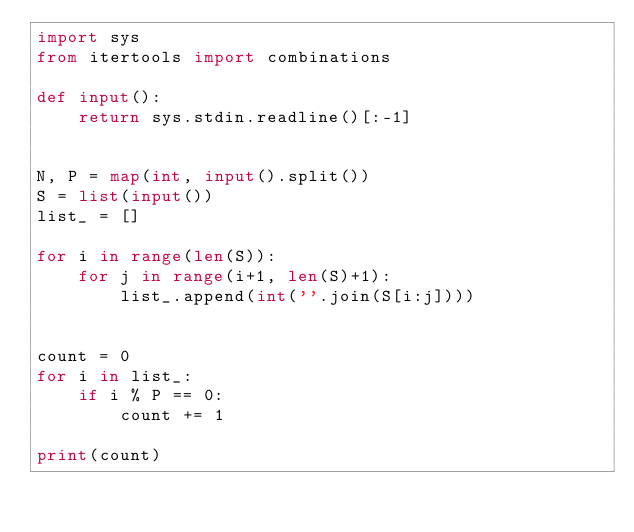Convert code to text. <code><loc_0><loc_0><loc_500><loc_500><_Python_>import sys
from itertools import combinations

def input():
    return sys.stdin.readline()[:-1]


N, P = map(int, input().split())
S = list(input())
list_ = []

for i in range(len(S)):
    for j in range(i+1, len(S)+1):
        list_.append(int(''.join(S[i:j])))


count = 0
for i in list_:
    if i % P == 0:
        count += 1

print(count)
</code> 